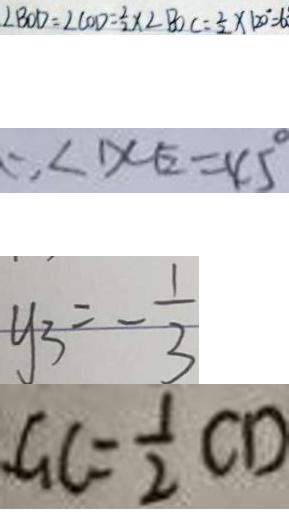<formula> <loc_0><loc_0><loc_500><loc_500>\angle B O D = \angle C O D = \frac { 2 } { 2 } \times \angle B O C = \frac { 1 } { 2 } \times 1 2 0 ^ { \circ } = 6 
 \therefore \angle D C E = 4 5 ^ { \circ } 
 y _ { 3 } = - \frac { 1 } { 3 } 
 G C = \frac { 1 } { 2 } C D</formula> 